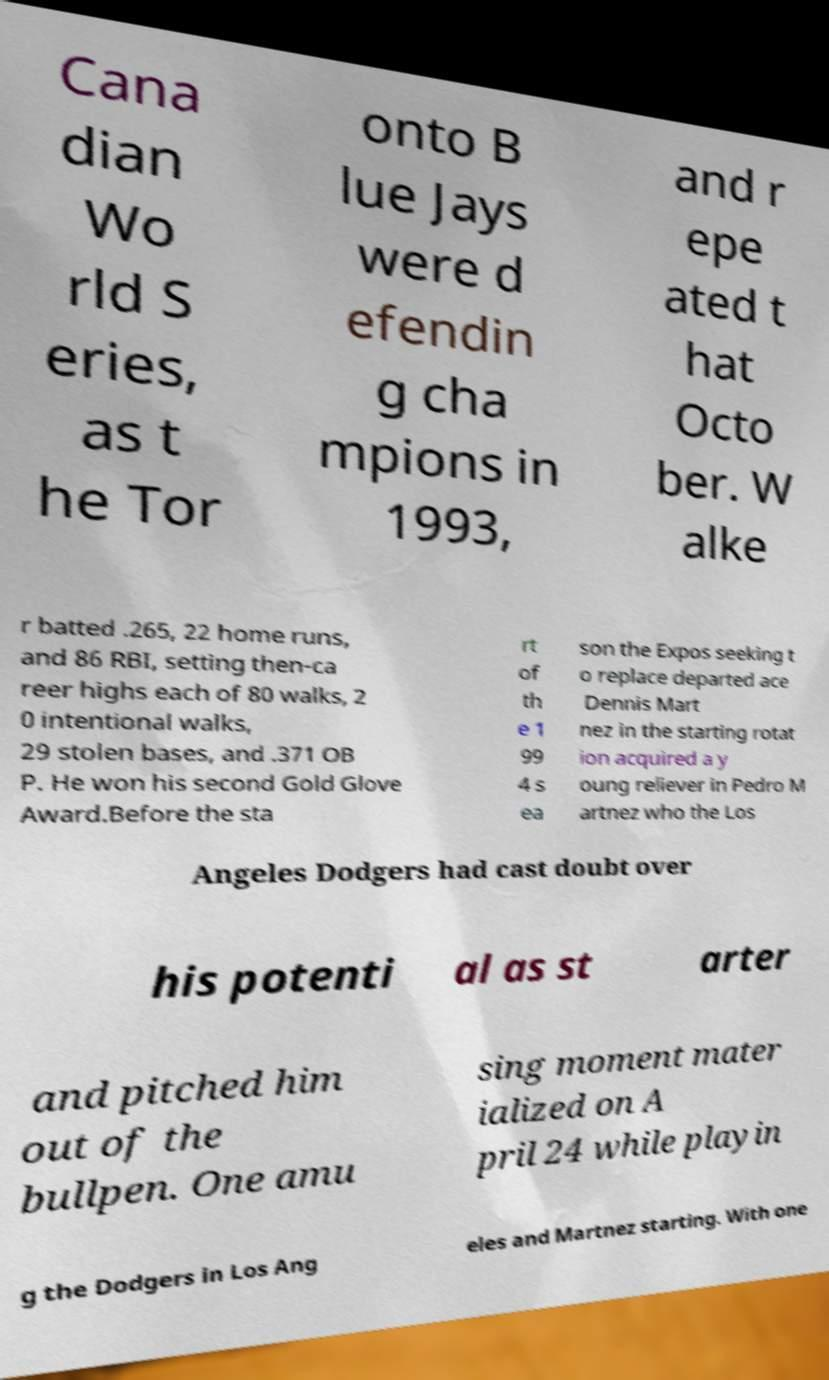Can you accurately transcribe the text from the provided image for me? Cana dian Wo rld S eries, as t he Tor onto B lue Jays were d efendin g cha mpions in 1993, and r epe ated t hat Octo ber. W alke r batted .265, 22 home runs, and 86 RBI, setting then-ca reer highs each of 80 walks, 2 0 intentional walks, 29 stolen bases, and .371 OB P. He won his second Gold Glove Award.Before the sta rt of th e 1 99 4 s ea son the Expos seeking t o replace departed ace Dennis Mart nez in the starting rotat ion acquired a y oung reliever in Pedro M artnez who the Los Angeles Dodgers had cast doubt over his potenti al as st arter and pitched him out of the bullpen. One amu sing moment mater ialized on A pril 24 while playin g the Dodgers in Los Ang eles and Martnez starting. With one 